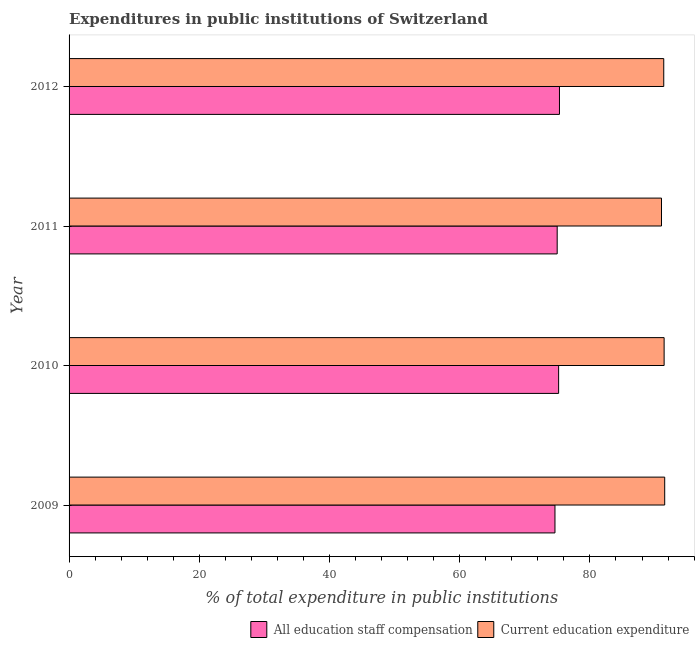How many different coloured bars are there?
Provide a short and direct response. 2. Are the number of bars per tick equal to the number of legend labels?
Keep it short and to the point. Yes. Are the number of bars on each tick of the Y-axis equal?
Provide a short and direct response. Yes. What is the label of the 4th group of bars from the top?
Ensure brevity in your answer.  2009. What is the expenditure in education in 2011?
Your answer should be compact. 90.99. Across all years, what is the maximum expenditure in staff compensation?
Offer a very short reply. 75.32. Across all years, what is the minimum expenditure in staff compensation?
Offer a very short reply. 74.63. In which year was the expenditure in education maximum?
Provide a succinct answer. 2009. What is the total expenditure in staff compensation in the graph?
Offer a very short reply. 300.11. What is the difference between the expenditure in education in 2011 and that in 2012?
Ensure brevity in your answer.  -0.35. What is the difference between the expenditure in staff compensation in 2012 and the expenditure in education in 2010?
Provide a short and direct response. -16.07. What is the average expenditure in education per year?
Give a very brief answer. 91.3. In the year 2011, what is the difference between the expenditure in staff compensation and expenditure in education?
Your answer should be very brief. -16.02. Is the expenditure in education in 2009 less than that in 2011?
Your answer should be very brief. No. What is the difference between the highest and the second highest expenditure in staff compensation?
Provide a succinct answer. 0.13. What is the difference between the highest and the lowest expenditure in education?
Keep it short and to the point. 0.49. What does the 1st bar from the top in 2012 represents?
Your answer should be compact. Current education expenditure. What does the 1st bar from the bottom in 2009 represents?
Ensure brevity in your answer.  All education staff compensation. How many bars are there?
Your answer should be very brief. 8. What is the difference between two consecutive major ticks on the X-axis?
Your answer should be compact. 20. Are the values on the major ticks of X-axis written in scientific E-notation?
Provide a short and direct response. No. Does the graph contain any zero values?
Keep it short and to the point. No. How are the legend labels stacked?
Offer a terse response. Horizontal. What is the title of the graph?
Ensure brevity in your answer.  Expenditures in public institutions of Switzerland. Does "Investment" appear as one of the legend labels in the graph?
Offer a terse response. No. What is the label or title of the X-axis?
Provide a succinct answer. % of total expenditure in public institutions. What is the label or title of the Y-axis?
Keep it short and to the point. Year. What is the % of total expenditure in public institutions of All education staff compensation in 2009?
Your response must be concise. 74.63. What is the % of total expenditure in public institutions of Current education expenditure in 2009?
Provide a short and direct response. 91.49. What is the % of total expenditure in public institutions in All education staff compensation in 2010?
Your answer should be very brief. 75.19. What is the % of total expenditure in public institutions in Current education expenditure in 2010?
Your answer should be very brief. 91.4. What is the % of total expenditure in public institutions in All education staff compensation in 2011?
Offer a terse response. 74.97. What is the % of total expenditure in public institutions in Current education expenditure in 2011?
Your response must be concise. 90.99. What is the % of total expenditure in public institutions in All education staff compensation in 2012?
Provide a succinct answer. 75.32. What is the % of total expenditure in public institutions of Current education expenditure in 2012?
Your response must be concise. 91.34. Across all years, what is the maximum % of total expenditure in public institutions in All education staff compensation?
Give a very brief answer. 75.32. Across all years, what is the maximum % of total expenditure in public institutions of Current education expenditure?
Give a very brief answer. 91.49. Across all years, what is the minimum % of total expenditure in public institutions in All education staff compensation?
Give a very brief answer. 74.63. Across all years, what is the minimum % of total expenditure in public institutions in Current education expenditure?
Offer a terse response. 90.99. What is the total % of total expenditure in public institutions in All education staff compensation in the graph?
Your response must be concise. 300.11. What is the total % of total expenditure in public institutions of Current education expenditure in the graph?
Provide a short and direct response. 365.21. What is the difference between the % of total expenditure in public institutions of All education staff compensation in 2009 and that in 2010?
Your response must be concise. -0.56. What is the difference between the % of total expenditure in public institutions in Current education expenditure in 2009 and that in 2010?
Your response must be concise. 0.09. What is the difference between the % of total expenditure in public institutions in All education staff compensation in 2009 and that in 2011?
Provide a succinct answer. -0.34. What is the difference between the % of total expenditure in public institutions of Current education expenditure in 2009 and that in 2011?
Offer a terse response. 0.49. What is the difference between the % of total expenditure in public institutions of All education staff compensation in 2009 and that in 2012?
Provide a succinct answer. -0.69. What is the difference between the % of total expenditure in public institutions of Current education expenditure in 2009 and that in 2012?
Provide a succinct answer. 0.15. What is the difference between the % of total expenditure in public institutions in All education staff compensation in 2010 and that in 2011?
Provide a short and direct response. 0.22. What is the difference between the % of total expenditure in public institutions in Current education expenditure in 2010 and that in 2011?
Offer a terse response. 0.4. What is the difference between the % of total expenditure in public institutions of All education staff compensation in 2010 and that in 2012?
Make the answer very short. -0.13. What is the difference between the % of total expenditure in public institutions of Current education expenditure in 2010 and that in 2012?
Provide a short and direct response. 0.06. What is the difference between the % of total expenditure in public institutions in All education staff compensation in 2011 and that in 2012?
Ensure brevity in your answer.  -0.35. What is the difference between the % of total expenditure in public institutions of Current education expenditure in 2011 and that in 2012?
Ensure brevity in your answer.  -0.35. What is the difference between the % of total expenditure in public institutions of All education staff compensation in 2009 and the % of total expenditure in public institutions of Current education expenditure in 2010?
Keep it short and to the point. -16.77. What is the difference between the % of total expenditure in public institutions in All education staff compensation in 2009 and the % of total expenditure in public institutions in Current education expenditure in 2011?
Your response must be concise. -16.36. What is the difference between the % of total expenditure in public institutions of All education staff compensation in 2009 and the % of total expenditure in public institutions of Current education expenditure in 2012?
Offer a terse response. -16.71. What is the difference between the % of total expenditure in public institutions in All education staff compensation in 2010 and the % of total expenditure in public institutions in Current education expenditure in 2011?
Your answer should be compact. -15.8. What is the difference between the % of total expenditure in public institutions in All education staff compensation in 2010 and the % of total expenditure in public institutions in Current education expenditure in 2012?
Ensure brevity in your answer.  -16.15. What is the difference between the % of total expenditure in public institutions of All education staff compensation in 2011 and the % of total expenditure in public institutions of Current education expenditure in 2012?
Provide a succinct answer. -16.37. What is the average % of total expenditure in public institutions of All education staff compensation per year?
Your answer should be compact. 75.03. What is the average % of total expenditure in public institutions of Current education expenditure per year?
Your answer should be very brief. 91.3. In the year 2009, what is the difference between the % of total expenditure in public institutions of All education staff compensation and % of total expenditure in public institutions of Current education expenditure?
Your answer should be compact. -16.86. In the year 2010, what is the difference between the % of total expenditure in public institutions in All education staff compensation and % of total expenditure in public institutions in Current education expenditure?
Make the answer very short. -16.2. In the year 2011, what is the difference between the % of total expenditure in public institutions in All education staff compensation and % of total expenditure in public institutions in Current education expenditure?
Give a very brief answer. -16.02. In the year 2012, what is the difference between the % of total expenditure in public institutions in All education staff compensation and % of total expenditure in public institutions in Current education expenditure?
Provide a short and direct response. -16.02. What is the ratio of the % of total expenditure in public institutions of Current education expenditure in 2009 to that in 2011?
Make the answer very short. 1.01. What is the ratio of the % of total expenditure in public institutions in Current education expenditure in 2009 to that in 2012?
Provide a succinct answer. 1. What is the ratio of the % of total expenditure in public institutions of Current education expenditure in 2010 to that in 2011?
Provide a succinct answer. 1. What is the difference between the highest and the second highest % of total expenditure in public institutions in All education staff compensation?
Give a very brief answer. 0.13. What is the difference between the highest and the second highest % of total expenditure in public institutions in Current education expenditure?
Ensure brevity in your answer.  0.09. What is the difference between the highest and the lowest % of total expenditure in public institutions of All education staff compensation?
Make the answer very short. 0.69. What is the difference between the highest and the lowest % of total expenditure in public institutions of Current education expenditure?
Give a very brief answer. 0.49. 